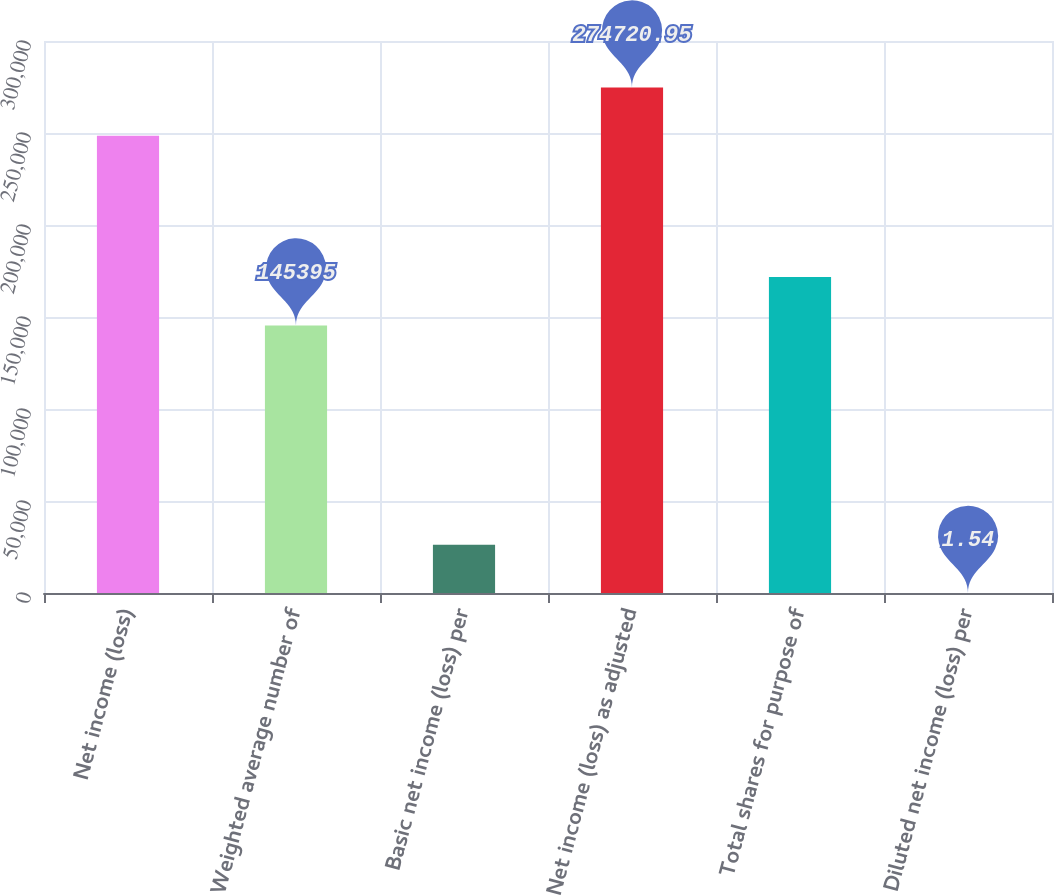Convert chart to OTSL. <chart><loc_0><loc_0><loc_500><loc_500><bar_chart><fcel>Net income (loss)<fcel>Weighted average number of<fcel>Basic net income (loss) per<fcel>Net income (loss) as adjusted<fcel>Total shares for purpose of<fcel>Diluted net income (loss) per<nl><fcel>248438<fcel>145395<fcel>26284.5<fcel>274721<fcel>171678<fcel>1.54<nl></chart> 